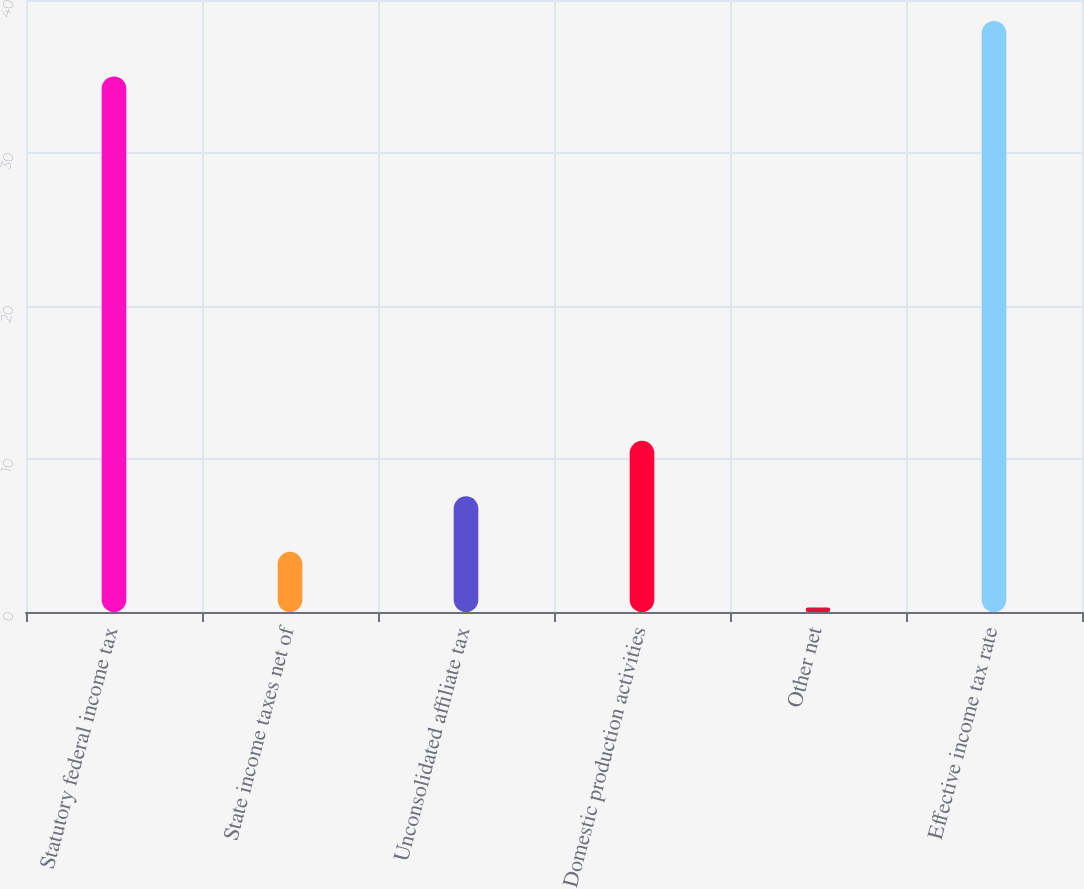<chart> <loc_0><loc_0><loc_500><loc_500><bar_chart><fcel>Statutory federal income tax<fcel>State income taxes net of<fcel>Unconsolidated affiliate tax<fcel>Domestic production activities<fcel>Other net<fcel>Effective income tax rate<nl><fcel>35<fcel>3.93<fcel>7.56<fcel>11.19<fcel>0.3<fcel>38.63<nl></chart> 